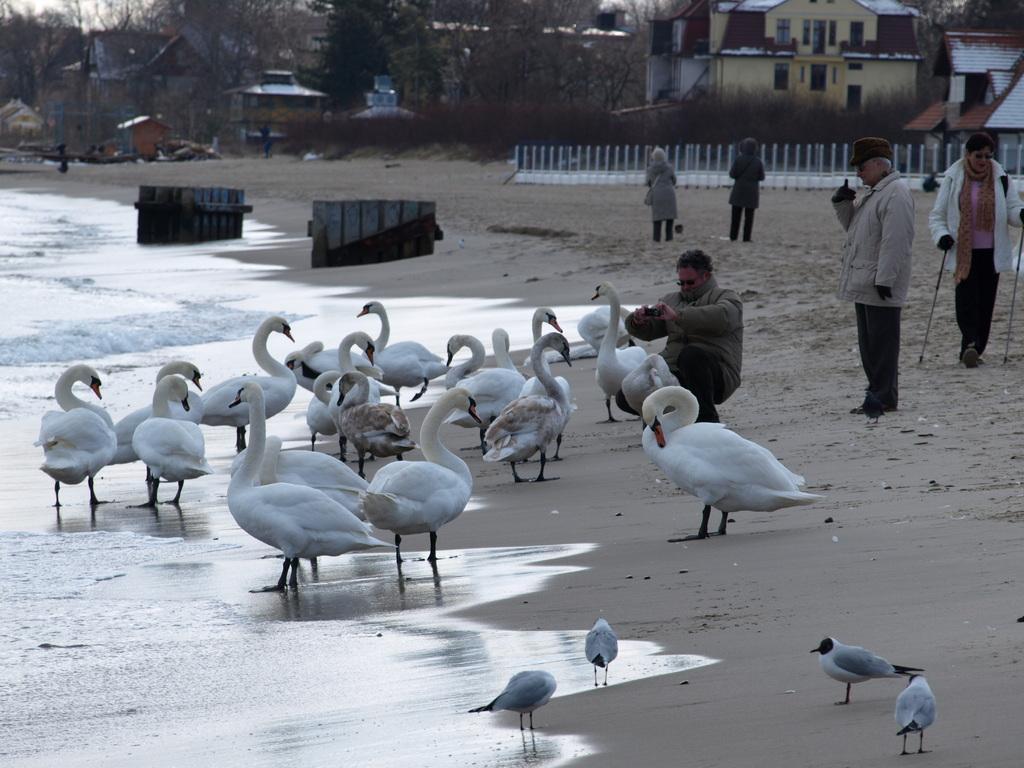Can you describe this image briefly? In the center of the image there are swans. At the bottom there are birds. On the left we can see water. On the right there are people standing and there is a man sitting and holding a camera in his hand. In the background there is a fence, building, trees and shed. 